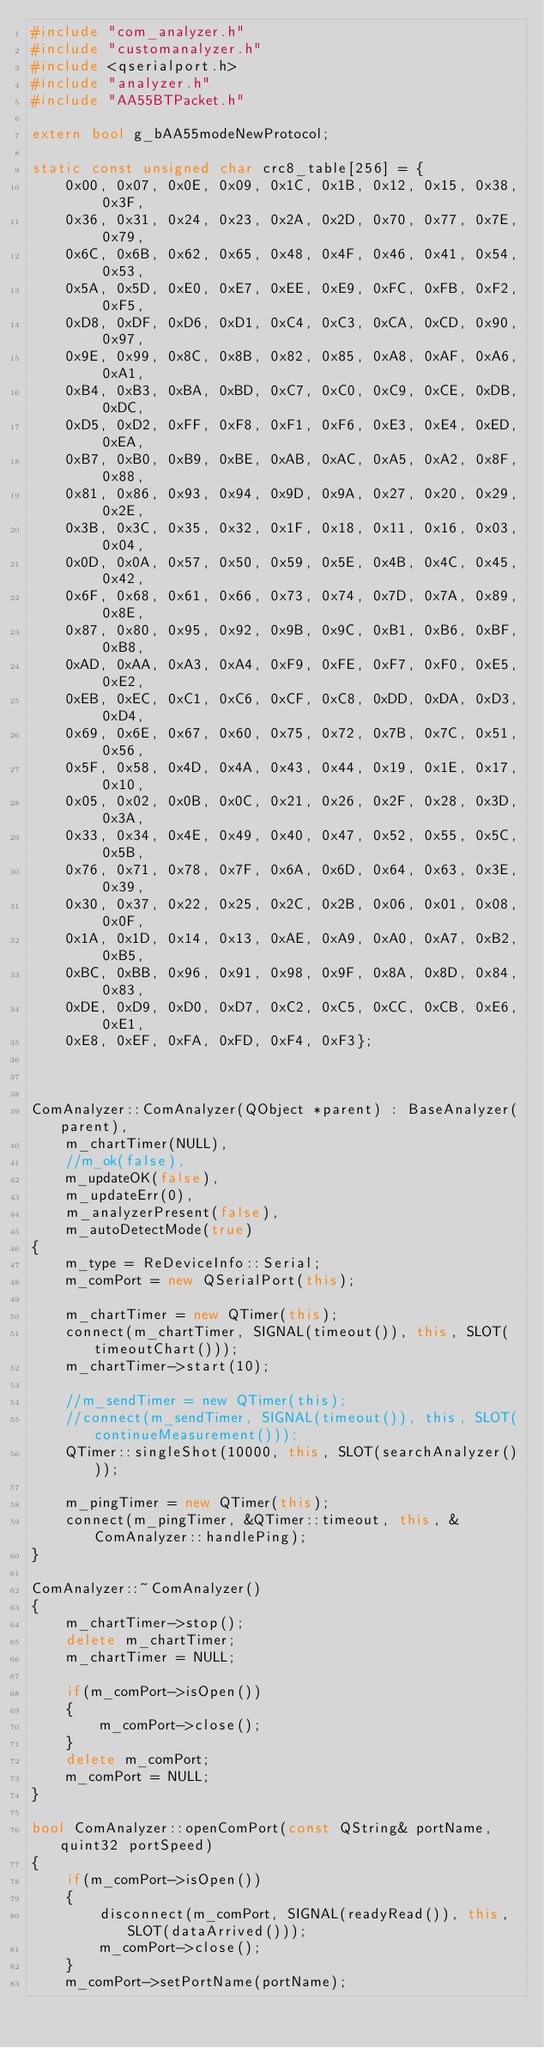Convert code to text. <code><loc_0><loc_0><loc_500><loc_500><_C++_>#include "com_analyzer.h"
#include "customanalyzer.h"
#include <qserialport.h>
#include "analyzer.h"
#include "AA55BTPacket.h"

extern bool g_bAA55modeNewProtocol;

static const unsigned char crc8_table[256] = {
    0x00, 0x07, 0x0E, 0x09, 0x1C, 0x1B, 0x12, 0x15, 0x38, 0x3F,
    0x36, 0x31, 0x24, 0x23, 0x2A, 0x2D, 0x70, 0x77, 0x7E, 0x79,
    0x6C, 0x6B, 0x62, 0x65, 0x48, 0x4F, 0x46, 0x41, 0x54, 0x53,
    0x5A, 0x5D, 0xE0, 0xE7, 0xEE, 0xE9, 0xFC, 0xFB, 0xF2, 0xF5,
    0xD8, 0xDF, 0xD6, 0xD1, 0xC4, 0xC3, 0xCA, 0xCD, 0x90, 0x97,
    0x9E, 0x99, 0x8C, 0x8B, 0x82, 0x85, 0xA8, 0xAF, 0xA6, 0xA1,
    0xB4, 0xB3, 0xBA, 0xBD, 0xC7, 0xC0, 0xC9, 0xCE, 0xDB, 0xDC,
    0xD5, 0xD2, 0xFF, 0xF8, 0xF1, 0xF6, 0xE3, 0xE4, 0xED, 0xEA,
    0xB7, 0xB0, 0xB9, 0xBE, 0xAB, 0xAC, 0xA5, 0xA2, 0x8F, 0x88,
    0x81, 0x86, 0x93, 0x94, 0x9D, 0x9A, 0x27, 0x20, 0x29, 0x2E,
    0x3B, 0x3C, 0x35, 0x32, 0x1F, 0x18, 0x11, 0x16, 0x03, 0x04,
    0x0D, 0x0A, 0x57, 0x50, 0x59, 0x5E, 0x4B, 0x4C, 0x45, 0x42,
    0x6F, 0x68, 0x61, 0x66, 0x73, 0x74, 0x7D, 0x7A, 0x89, 0x8E,
    0x87, 0x80, 0x95, 0x92, 0x9B, 0x9C, 0xB1, 0xB6, 0xBF, 0xB8,
    0xAD, 0xAA, 0xA3, 0xA4, 0xF9, 0xFE, 0xF7, 0xF0, 0xE5, 0xE2,
    0xEB, 0xEC, 0xC1, 0xC6, 0xCF, 0xC8, 0xDD, 0xDA, 0xD3, 0xD4,
    0x69, 0x6E, 0x67, 0x60, 0x75, 0x72, 0x7B, 0x7C, 0x51, 0x56,
    0x5F, 0x58, 0x4D, 0x4A, 0x43, 0x44, 0x19, 0x1E, 0x17, 0x10,
    0x05, 0x02, 0x0B, 0x0C, 0x21, 0x26, 0x2F, 0x28, 0x3D, 0x3A,
    0x33, 0x34, 0x4E, 0x49, 0x40, 0x47, 0x52, 0x55, 0x5C, 0x5B,
    0x76, 0x71, 0x78, 0x7F, 0x6A, 0x6D, 0x64, 0x63, 0x3E, 0x39,
    0x30, 0x37, 0x22, 0x25, 0x2C, 0x2B, 0x06, 0x01, 0x08, 0x0F,
    0x1A, 0x1D, 0x14, 0x13, 0xAE, 0xA9, 0xA0, 0xA7, 0xB2, 0xB5,
    0xBC, 0xBB, 0x96, 0x91, 0x98, 0x9F, 0x8A, 0x8D, 0x84, 0x83,
    0xDE, 0xD9, 0xD0, 0xD7, 0xC2, 0xC5, 0xCC, 0xCB, 0xE6, 0xE1,
    0xE8, 0xEF, 0xFA, 0xFD, 0xF4, 0xF3};



ComAnalyzer::ComAnalyzer(QObject *parent) : BaseAnalyzer(parent),
    m_chartTimer(NULL),
    //m_ok(false),
    m_updateOK(false),
    m_updateErr(0),
    m_analyzerPresent(false),
    m_autoDetectMode(true)
{
    m_type = ReDeviceInfo::Serial;
    m_comPort = new QSerialPort(this);

    m_chartTimer = new QTimer(this);
    connect(m_chartTimer, SIGNAL(timeout()), this, SLOT(timeoutChart()));
    m_chartTimer->start(10);

    //m_sendTimer = new QTimer(this);
    //connect(m_sendTimer, SIGNAL(timeout()), this, SLOT(continueMeasurement()));
    QTimer::singleShot(10000, this, SLOT(searchAnalyzer()));

    m_pingTimer = new QTimer(this);
    connect(m_pingTimer, &QTimer::timeout, this, &ComAnalyzer::handlePing);
}

ComAnalyzer::~ComAnalyzer()
{
    m_chartTimer->stop();
    delete m_chartTimer;
    m_chartTimer = NULL;

    if(m_comPort->isOpen())
    {
        m_comPort->close();
    }
    delete m_comPort;
    m_comPort = NULL;
}

bool ComAnalyzer::openComPort(const QString& portName, quint32 portSpeed)
{
    if(m_comPort->isOpen())
    {
        disconnect(m_comPort, SIGNAL(readyRead()), this, SLOT(dataArrived()));
        m_comPort->close();
    }
    m_comPort->setPortName(portName);</code> 